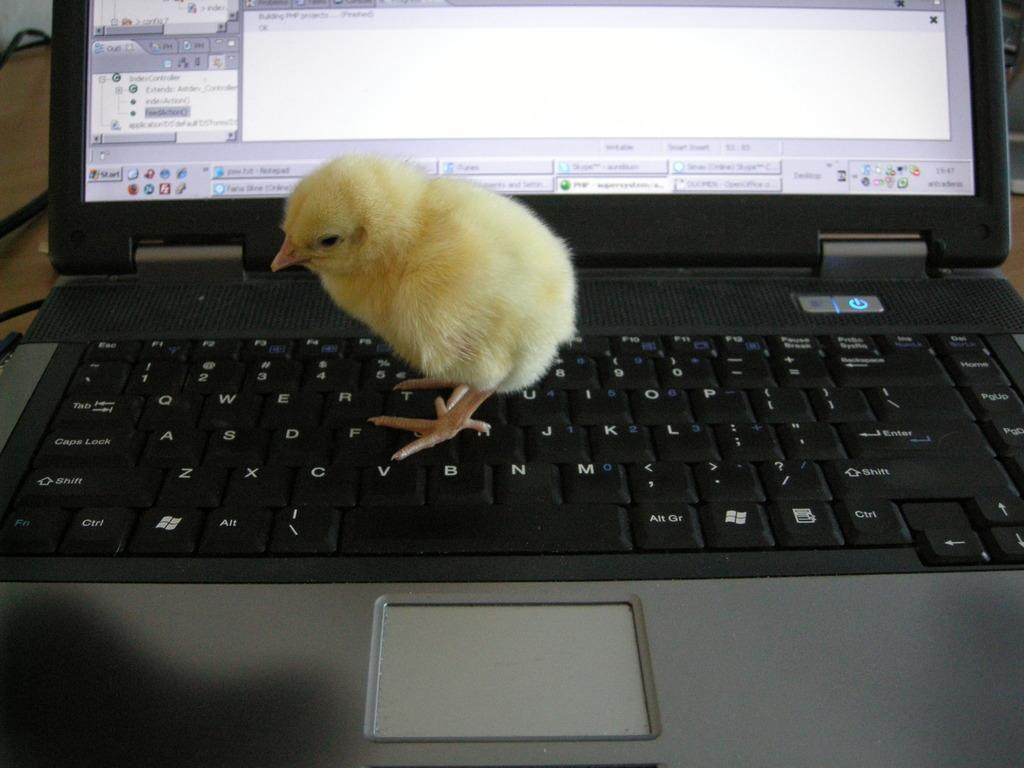What type of animal is in the image? There is a chick in the image. Where is the chick located? The chick is on a laptop. What type of beef is being discussed in the argument on the laptop? There is no beef or argument present in the image; it features a chick on a laptop. 